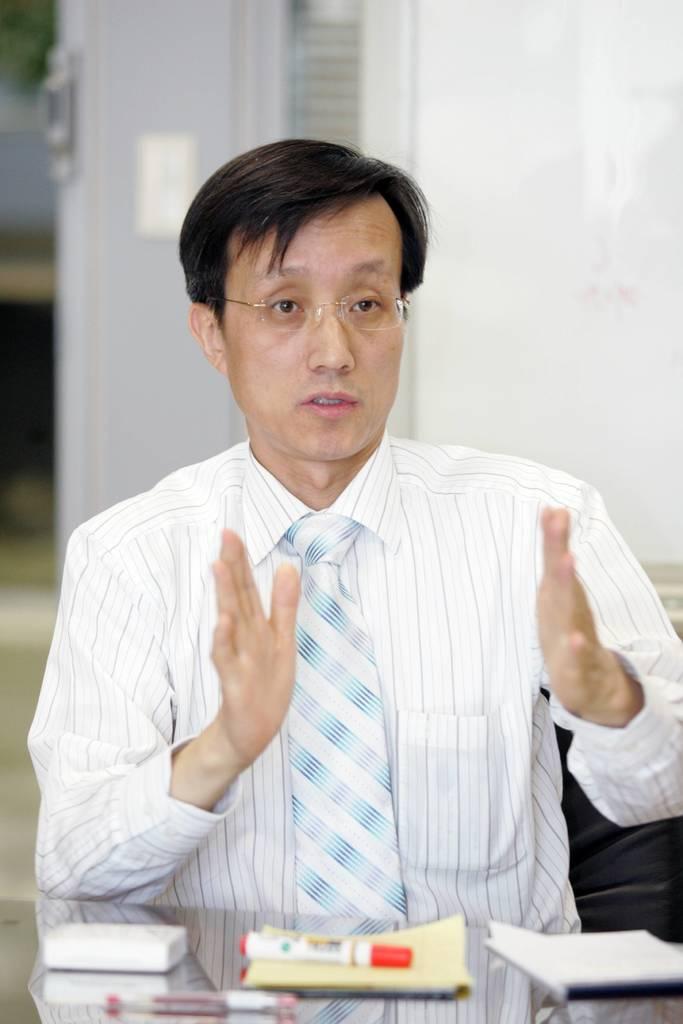In one or two sentences, can you explain what this image depicts? In this image there is a man sitting in a chair and talking about something in the table and in table there are bookmarks ,napkin , pen, and the back ground there is a door. 